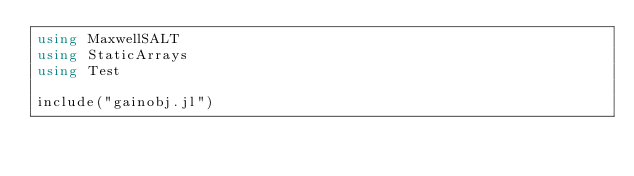Convert code to text. <code><loc_0><loc_0><loc_500><loc_500><_Julia_>using MaxwellSALT
using StaticArrays
using Test

include("gainobj.jl")
</code> 